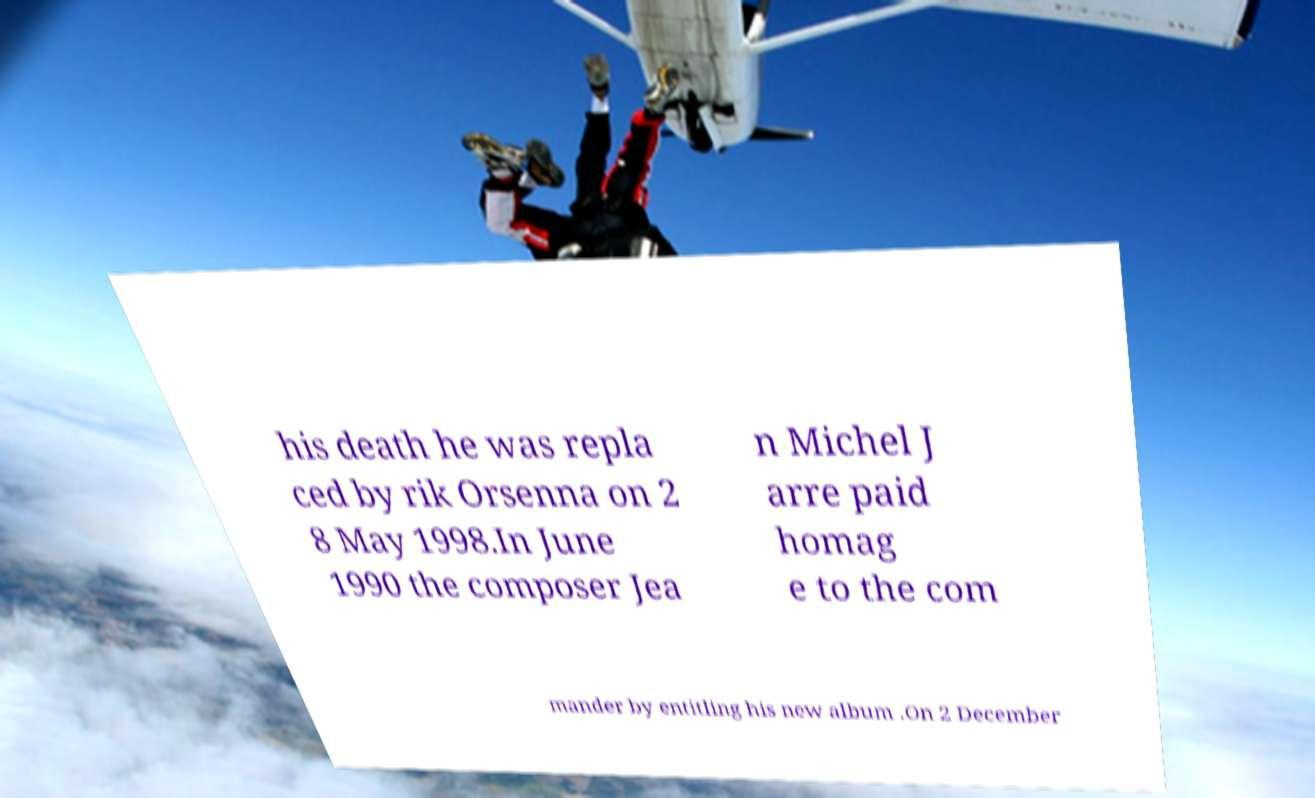There's text embedded in this image that I need extracted. Can you transcribe it verbatim? his death he was repla ced by rik Orsenna on 2 8 May 1998.In June 1990 the composer Jea n Michel J arre paid homag e to the com mander by entitling his new album .On 2 December 